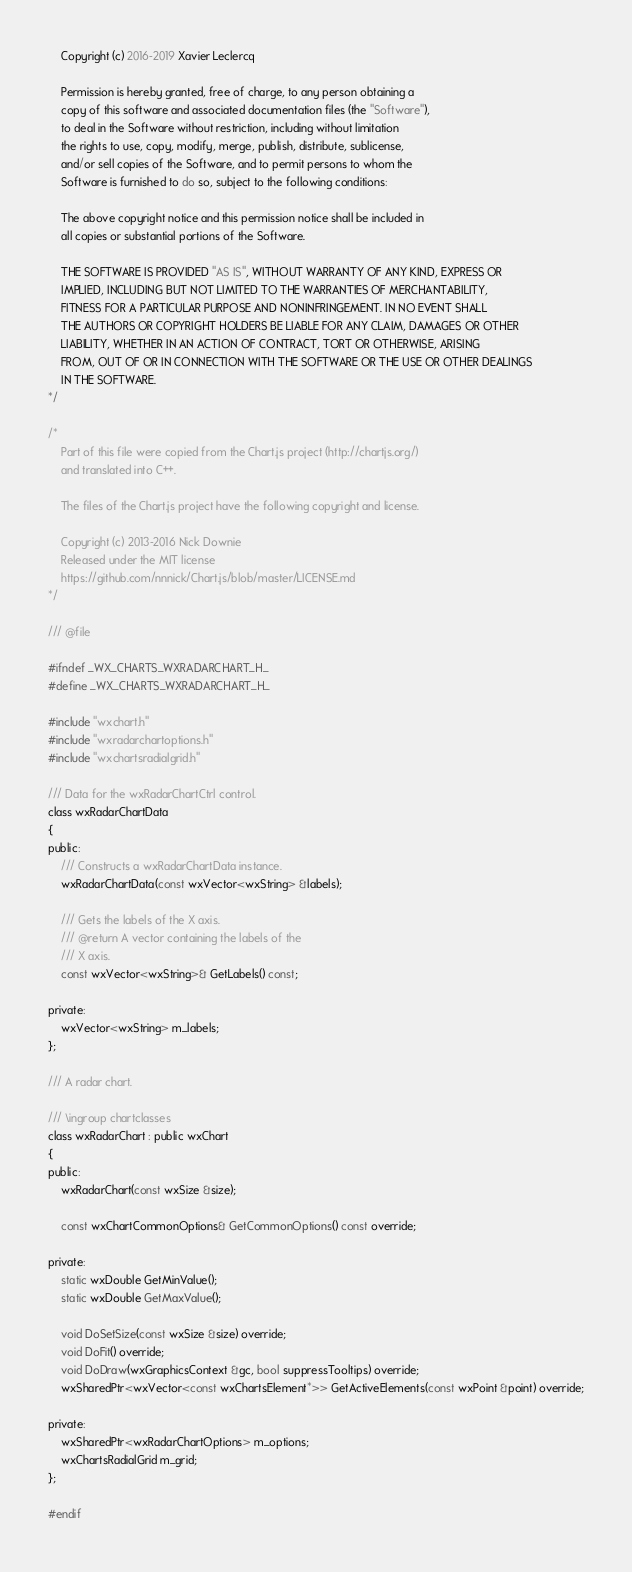Convert code to text. <code><loc_0><loc_0><loc_500><loc_500><_C_>    Copyright (c) 2016-2019 Xavier Leclercq

    Permission is hereby granted, free of charge, to any person obtaining a
    copy of this software and associated documentation files (the "Software"),
    to deal in the Software without restriction, including without limitation
    the rights to use, copy, modify, merge, publish, distribute, sublicense,
    and/or sell copies of the Software, and to permit persons to whom the
    Software is furnished to do so, subject to the following conditions:

    The above copyright notice and this permission notice shall be included in
    all copies or substantial portions of the Software.

    THE SOFTWARE IS PROVIDED "AS IS", WITHOUT WARRANTY OF ANY KIND, EXPRESS OR
    IMPLIED, INCLUDING BUT NOT LIMITED TO THE WARRANTIES OF MERCHANTABILITY,
    FITNESS FOR A PARTICULAR PURPOSE AND NONINFRINGEMENT. IN NO EVENT SHALL
    THE AUTHORS OR COPYRIGHT HOLDERS BE LIABLE FOR ANY CLAIM, DAMAGES OR OTHER
    LIABILITY, WHETHER IN AN ACTION OF CONTRACT, TORT OR OTHERWISE, ARISING
    FROM, OUT OF OR IN CONNECTION WITH THE SOFTWARE OR THE USE OR OTHER DEALINGS
    IN THE SOFTWARE.
*/

/*
    Part of this file were copied from the Chart.js project (http://chartjs.org/)
    and translated into C++.

    The files of the Chart.js project have the following copyright and license.

    Copyright (c) 2013-2016 Nick Downie
    Released under the MIT license
    https://github.com/nnnick/Chart.js/blob/master/LICENSE.md
*/

/// @file

#ifndef _WX_CHARTS_WXRADARCHART_H_
#define _WX_CHARTS_WXRADARCHART_H_

#include "wxchart.h"
#include "wxradarchartoptions.h"
#include "wxchartsradialgrid.h"

/// Data for the wxRadarChartCtrl control.
class wxRadarChartData
{
public:
    /// Constructs a wxRadarChartData instance.
    wxRadarChartData(const wxVector<wxString> &labels);

    /// Gets the labels of the X axis.
    /// @return A vector containing the labels of the
    /// X axis.
    const wxVector<wxString>& GetLabels() const;

private:
    wxVector<wxString> m_labels;
};

/// A radar chart.

/// \ingroup chartclasses
class wxRadarChart : public wxChart
{
public:
    wxRadarChart(const wxSize &size);

    const wxChartCommonOptions& GetCommonOptions() const override;

private:
    static wxDouble GetMinValue();
    static wxDouble GetMaxValue();

    void DoSetSize(const wxSize &size) override;
    void DoFit() override;
    void DoDraw(wxGraphicsContext &gc, bool suppressTooltips) override;
    wxSharedPtr<wxVector<const wxChartsElement*>> GetActiveElements(const wxPoint &point) override;

private:
    wxSharedPtr<wxRadarChartOptions> m_options;
    wxChartsRadialGrid m_grid;
};

#endif
</code> 